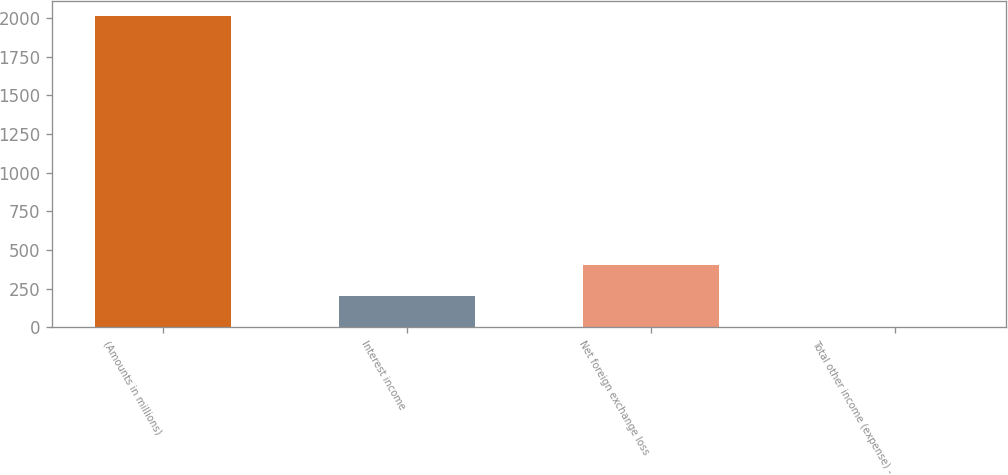Convert chart to OTSL. <chart><loc_0><loc_0><loc_500><loc_500><bar_chart><fcel>(Amounts in millions)<fcel>Interest income<fcel>Net foreign exchange loss<fcel>Total other income (expense) -<nl><fcel>2011<fcel>202<fcel>403<fcel>1<nl></chart> 